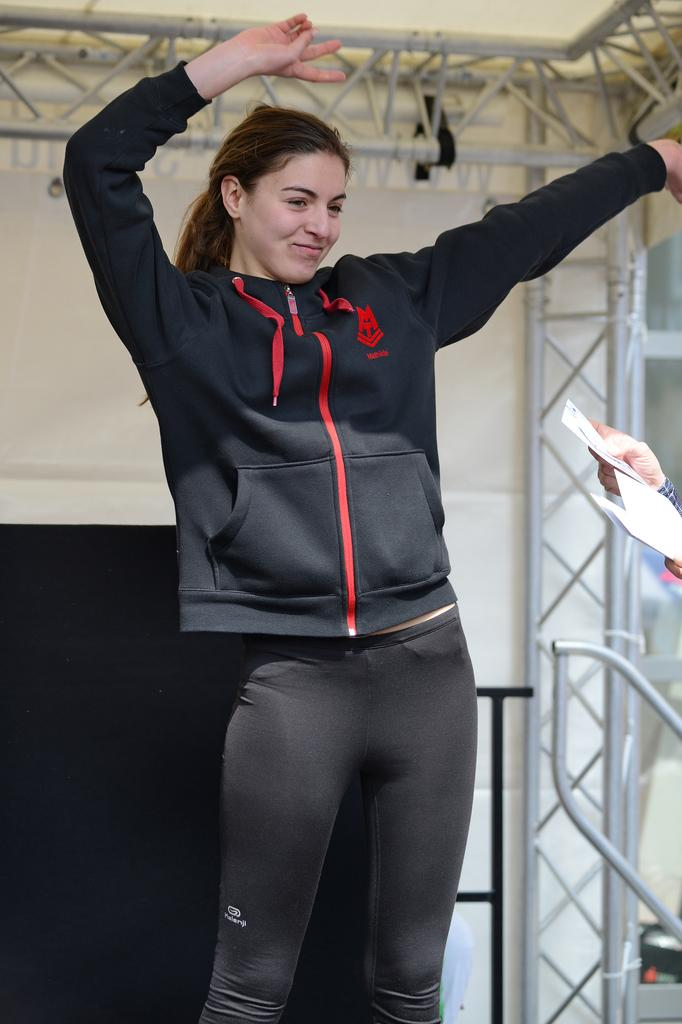Who is present in the image? There is a woman in the image. What is the woman doing in the image? The woman is smiling. What object is being held by a person in the image? There is a hand of a person holding a paper. What can be seen in the background of the image? There is a wall and rods in the background of the image. What type of cakes are being rewarded to the woman in the image? There is no mention of cakes or rewards in the image; it only shows a woman smiling and a hand holding a paper. 